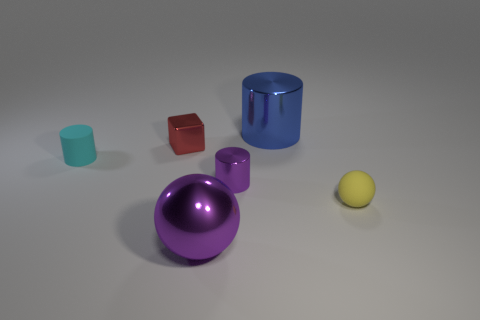Add 3 green cubes. How many objects exist? 9 Subtract all cubes. How many objects are left? 5 Subtract all green rubber balls. Subtract all small metallic things. How many objects are left? 4 Add 1 small cyan matte cylinders. How many small cyan matte cylinders are left? 2 Add 1 purple spheres. How many purple spheres exist? 2 Subtract 0 blue blocks. How many objects are left? 6 